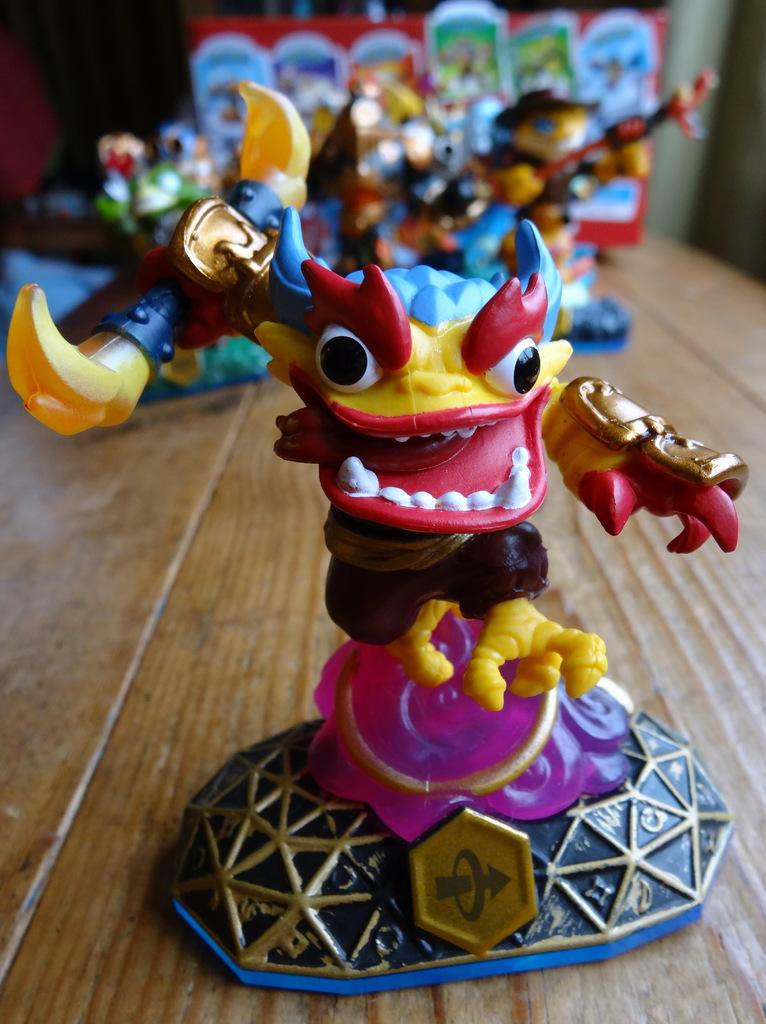What type of objects can be seen in the image? There are toys in the image. What type of spark can be seen coming from the toys in the image? There is no spark present in the image; it only features toys. Where is the basket located in the image? There is no basket present in the image; it only features toys. 